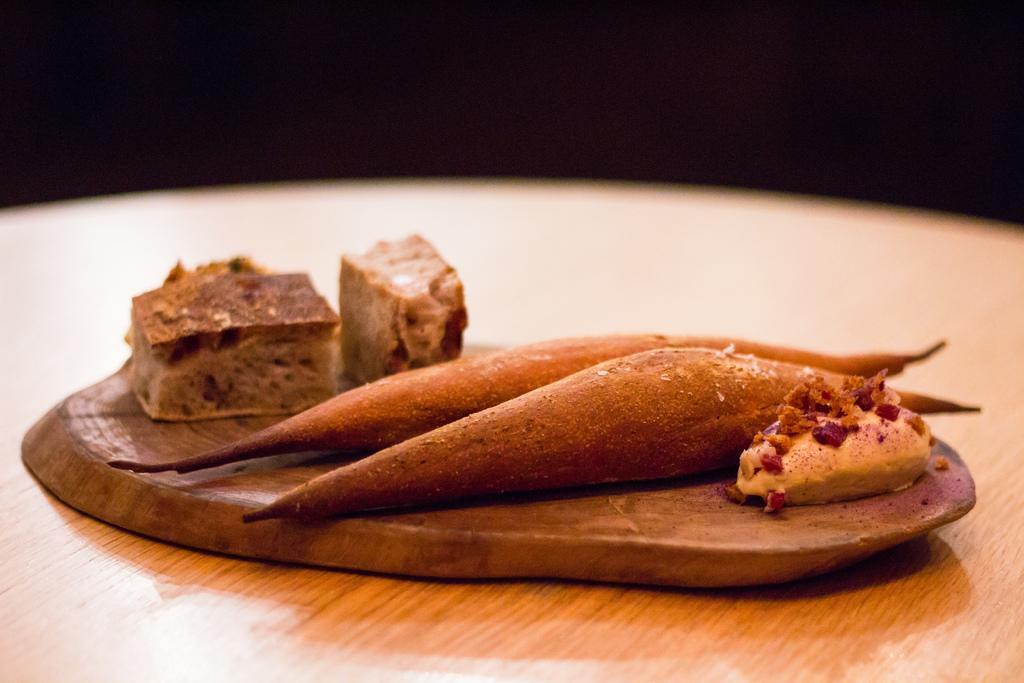Can you describe this image briefly? In this image we can see the food items on the wooden surface which is on the wooden table and the background is in black color. 